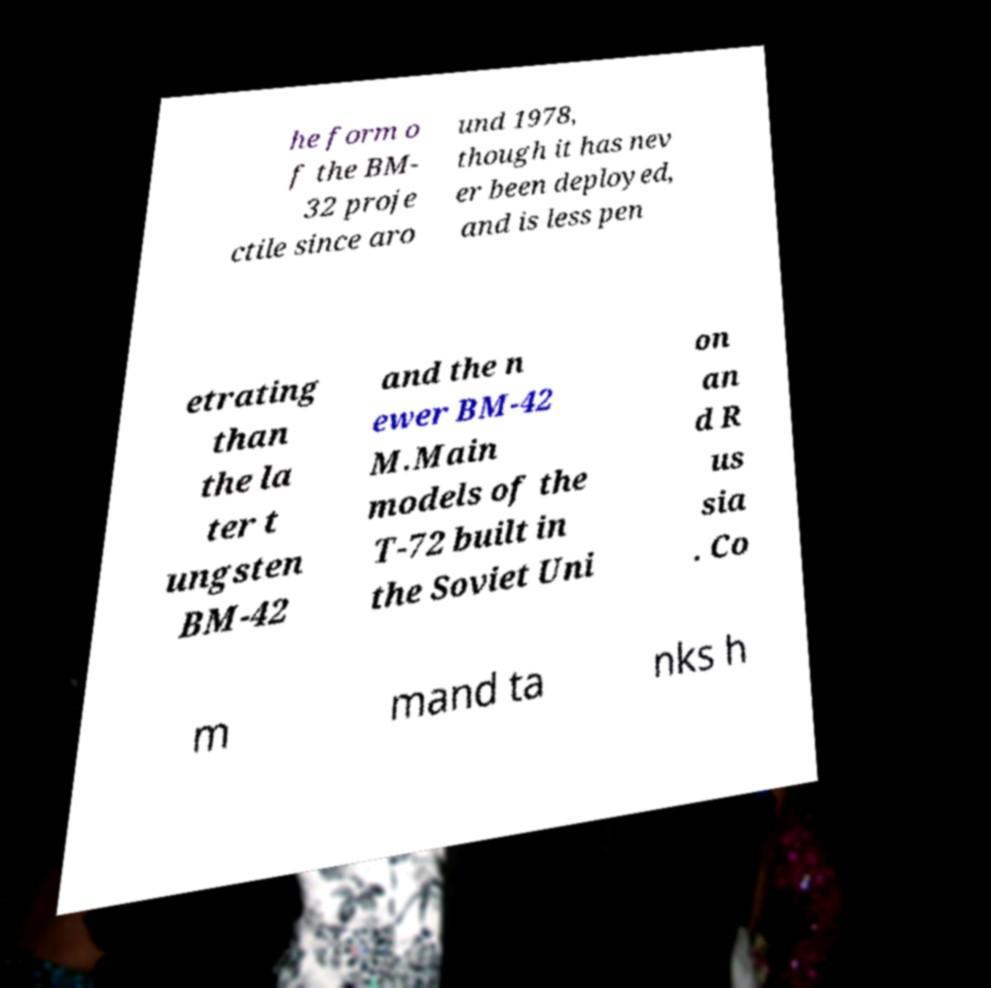Can you accurately transcribe the text from the provided image for me? he form o f the BM- 32 proje ctile since aro und 1978, though it has nev er been deployed, and is less pen etrating than the la ter t ungsten BM-42 and the n ewer BM-42 M.Main models of the T-72 built in the Soviet Uni on an d R us sia . Co m mand ta nks h 